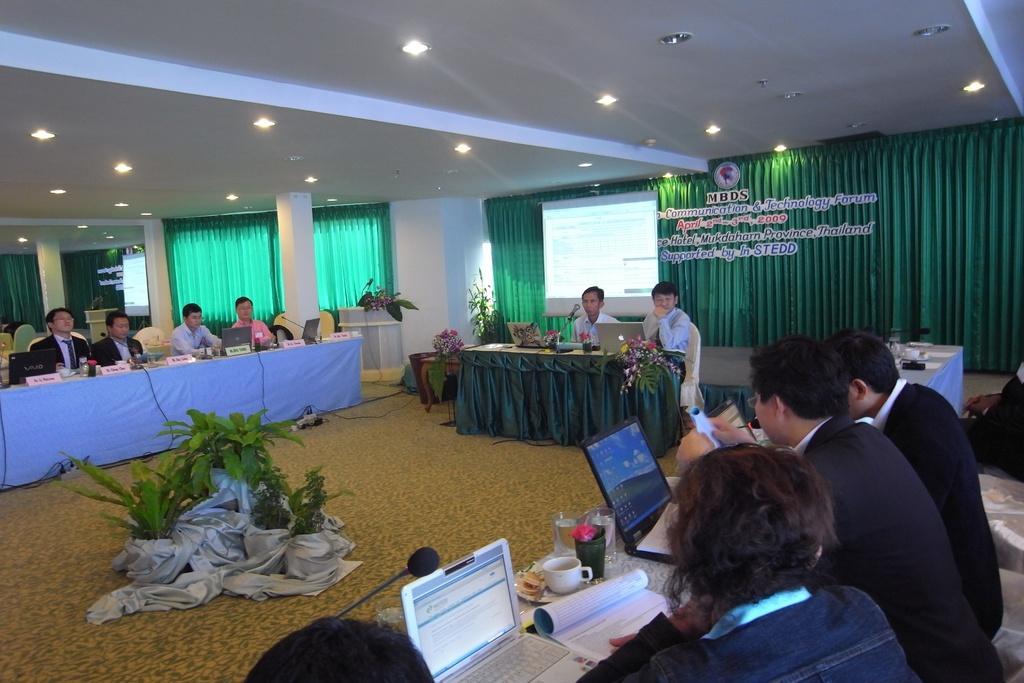Describe this image in one or two sentences. In this image there are group of people who are sitting on chairs, and also there are some tables. On the tables we could see some bottles, laptops, papers, cups, glasses and some flowers. In the background there are some curtains, windows and pillars, in the foreground there are some flower pots and plants. On the top there is ceiling and some lights. 